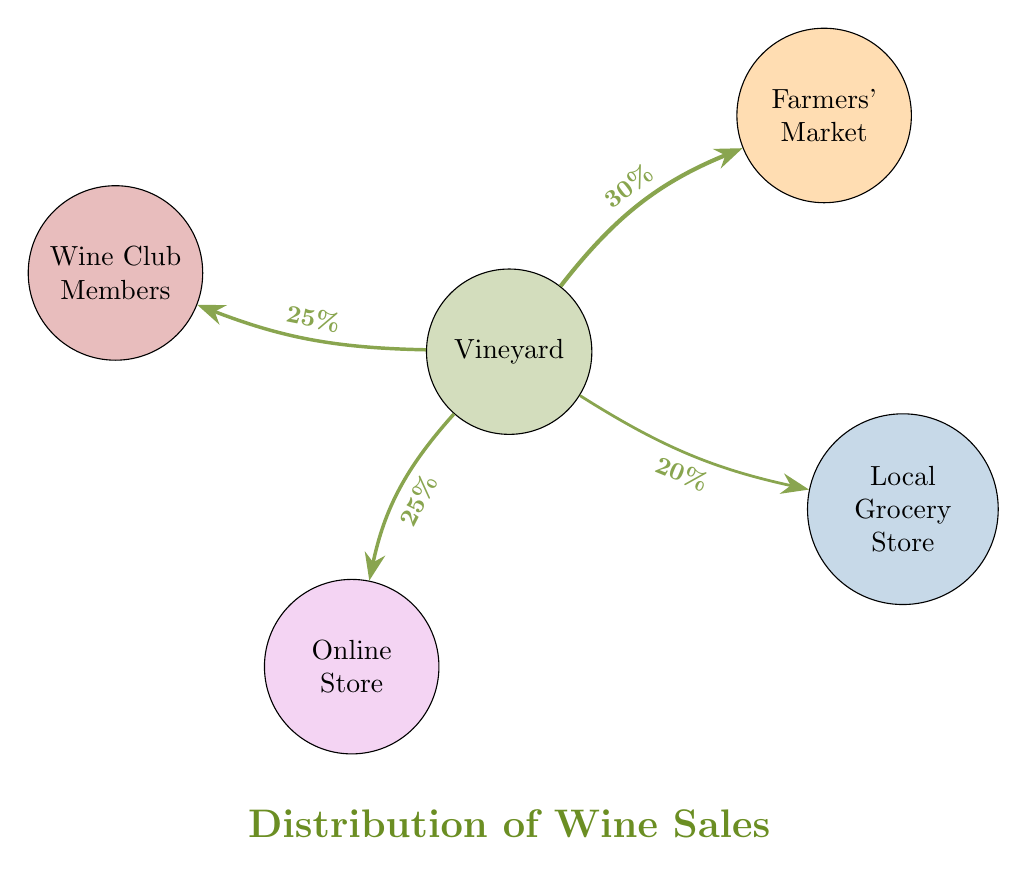What is the sales percentage attributed to the Farmers' Market? The diagram shows a link from the Vineyard to the Farmers' Market with a label indicating a sales percentage of 30%.
Answer: 30% What is the total number of nodes in the diagram? The diagram lists five nodes: Vineyard, Farmers' Market, Local Grocery Store, Online Store, and Wine Club Members. Therefore, the total count of nodes is 5.
Answer: 5 Which channel has the lowest sales percentage? By examining the links from the Vineyard, the Local Grocery Store shows a sales percentage of 20%, which is the lowest when compared to the other channels.
Answer: Local Grocery Store What percentage of sales goes to Wine Club Members compared to Online Store? The diagram indicates that both the Wine Club Members and Online Store receive 25% of sales, thus both channels are equal in sales percentage.
Answer: Equal (25%) How does the sales distribution to Local Grocery Store relate to Wine Club Members in terms of percentages? The Local Grocery Store has a sales percentage of 20%, whereas Wine Club Members have 25%. Therefore, the Wine Club Members receive 5% more in sales than the Local Grocery Store.
Answer: 5% What proportion of total sales comes from Farmers' Market compared to the total sales from Online Store and Wine Club Members combined? Farmers' Market contributes 30%, while Online Store and Wine Club Members combined contribute 50% (25% + 25%). The Farmers' Market accounts for 30% out of a total of 80% from these three channels (30% + 20% + 25% + 25%), which translates to 37.5% of these chosen channels, showing its relative significance.
Answer: 37.5% What color represents the Online Store in the diagram? The Online Store is represented by the color purple, as denoted in the diagram's color scheme.
Answer: Purple Which two channels account for the highest combined sales percentage? The Farmers' Market at 30% and Wine Club Members at 25% account for the highest combined sales percentage, totaling 55%.
Answer: 55% 